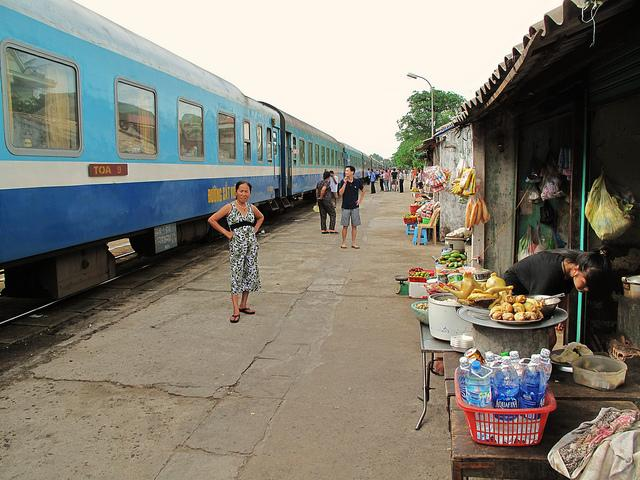What is the person on the right selling? Please explain your reasoning. water. There are bottles of clear liquid in a basket 